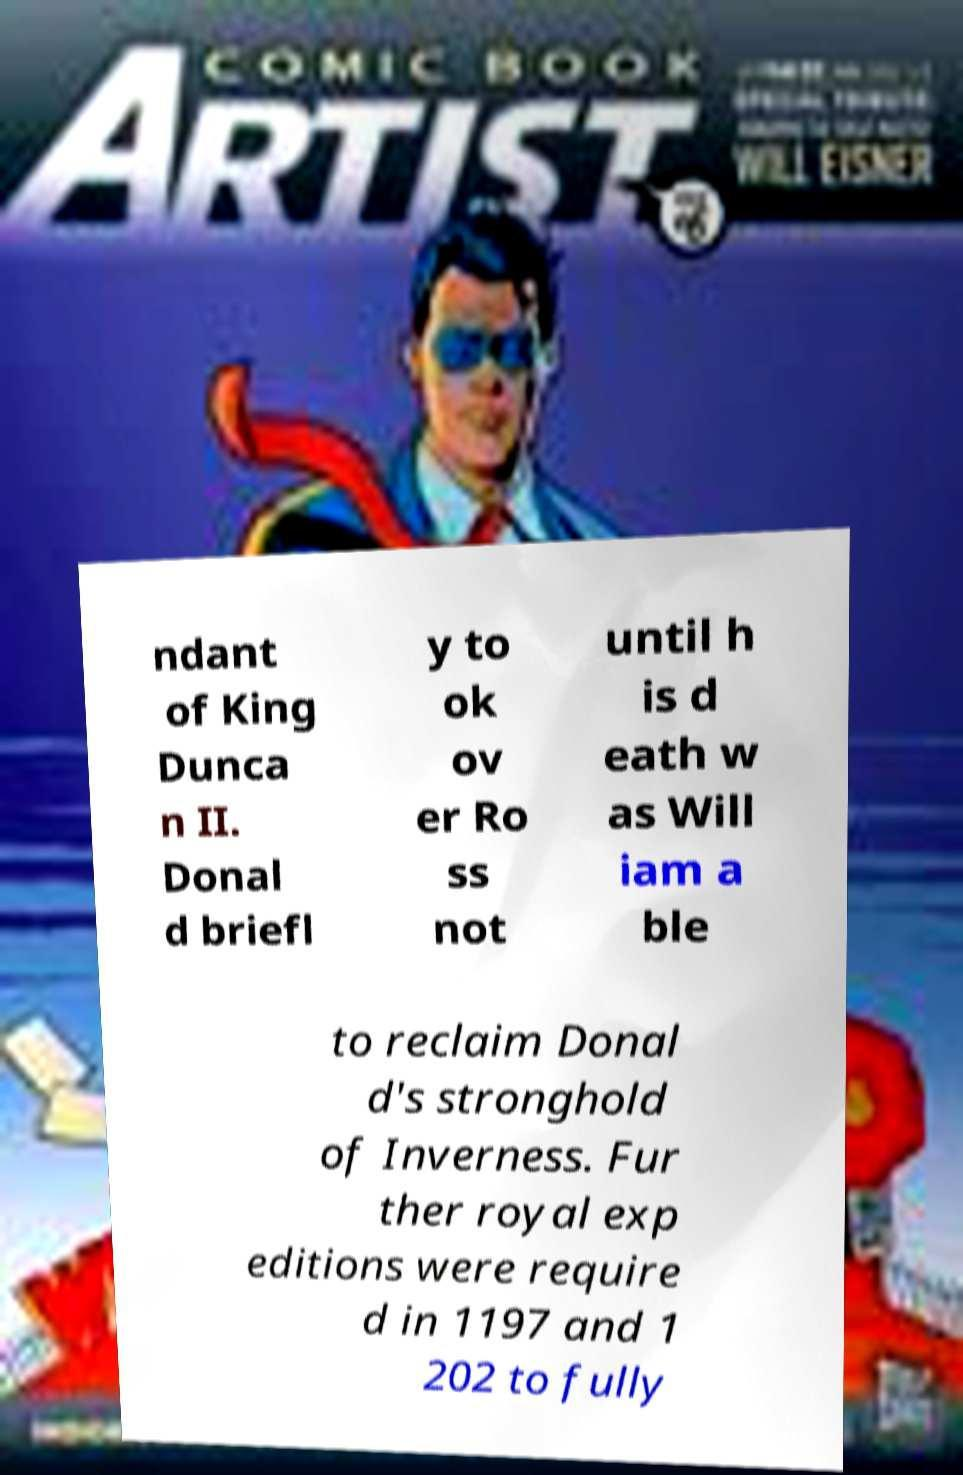Could you extract and type out the text from this image? ndant of King Dunca n II. Donal d briefl y to ok ov er Ro ss not until h is d eath w as Will iam a ble to reclaim Donal d's stronghold of Inverness. Fur ther royal exp editions were require d in 1197 and 1 202 to fully 